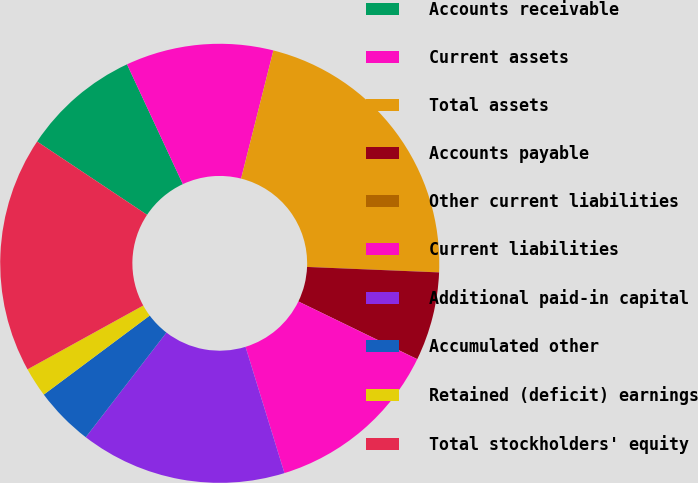<chart> <loc_0><loc_0><loc_500><loc_500><pie_chart><fcel>Accounts receivable<fcel>Current assets<fcel>Total assets<fcel>Accounts payable<fcel>Other current liabilities<fcel>Current liabilities<fcel>Additional paid-in capital<fcel>Accumulated other<fcel>Retained (deficit) earnings<fcel>Total stockholders' equity<nl><fcel>8.7%<fcel>10.87%<fcel>21.73%<fcel>6.53%<fcel>0.01%<fcel>13.04%<fcel>15.21%<fcel>4.35%<fcel>2.18%<fcel>17.38%<nl></chart> 